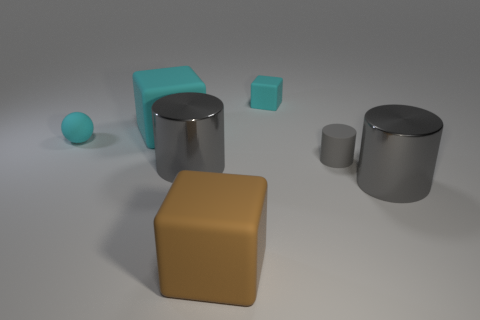The big shiny object that is behind the gray shiny object that is right of the tiny cyan cube is what color?
Offer a very short reply. Gray. How many other things are there of the same shape as the large cyan rubber thing?
Give a very brief answer. 2. Are there any small gray things made of the same material as the small cyan ball?
Your answer should be very brief. Yes. There is a cyan cube that is the same size as the gray rubber thing; what is it made of?
Your answer should be very brief. Rubber. There is a large metal cylinder that is behind the big metal thing on the right side of the shiny cylinder that is left of the tiny cyan block; what is its color?
Your answer should be very brief. Gray. Does the cyan thing behind the large cyan thing have the same shape as the large gray object that is left of the big brown matte cube?
Make the answer very short. No. What number of small cyan matte objects are there?
Provide a succinct answer. 2. There is a matte sphere that is the same size as the gray rubber object; what color is it?
Make the answer very short. Cyan. Are the cylinder on the left side of the matte cylinder and the large object behind the tiny ball made of the same material?
Give a very brief answer. No. How big is the cyan matte block that is to the right of the gray cylinder that is to the left of the small gray thing?
Keep it short and to the point. Small. 